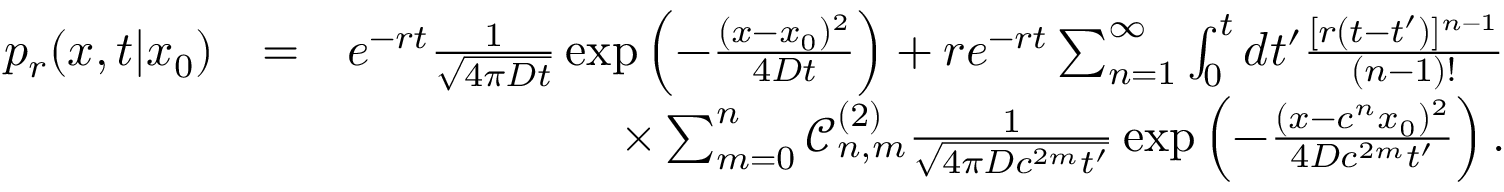Convert formula to latex. <formula><loc_0><loc_0><loc_500><loc_500>\begin{array} { r l r } { p _ { r } ( x , t | x _ { 0 } ) } & { = } & { e ^ { - r t } \frac { 1 } { \sqrt { 4 \pi D t } } \exp \left ( - \frac { ( x - x _ { 0 } ) ^ { 2 } } { 4 D t } \right ) + r e ^ { - r t } \sum _ { n = 1 } ^ { \infty } \int _ { 0 } ^ { t } d t ^ { \prime } \frac { [ r ( t - t ^ { \prime } ) ] ^ { n - 1 } } { ( n - 1 ) ! } } \\ & { \times \sum _ { m = 0 } ^ { n } \mathcal { C } _ { n , m } ^ { ( 2 ) } \frac { 1 } { \sqrt { 4 \pi D c ^ { 2 m } t ^ { \prime } } } \exp \left ( - \frac { ( x - c ^ { n } x _ { 0 } ) ^ { 2 } } { 4 D c ^ { 2 m } t ^ { \prime } } \right ) . } \end{array}</formula> 